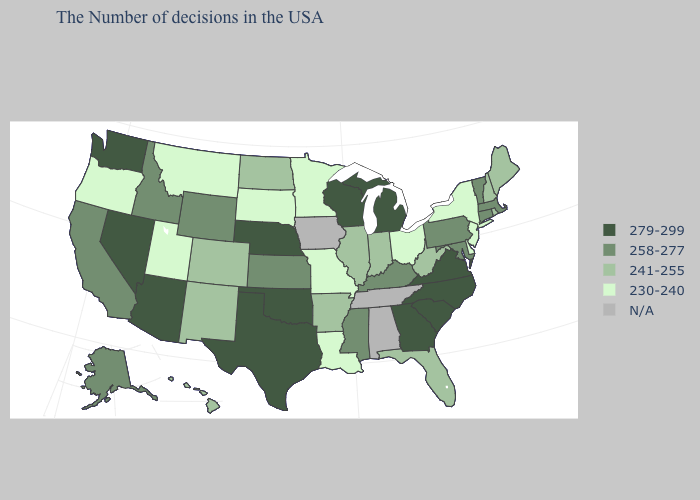Among the states that border Arkansas , which have the lowest value?
Quick response, please. Louisiana, Missouri. Name the states that have a value in the range 241-255?
Quick response, please. Maine, Rhode Island, New Hampshire, West Virginia, Florida, Indiana, Illinois, Arkansas, North Dakota, Colorado, New Mexico, Hawaii. What is the value of Florida?
Quick response, please. 241-255. Does Ohio have the lowest value in the USA?
Quick response, please. Yes. How many symbols are there in the legend?
Write a very short answer. 5. Name the states that have a value in the range 241-255?
Give a very brief answer. Maine, Rhode Island, New Hampshire, West Virginia, Florida, Indiana, Illinois, Arkansas, North Dakota, Colorado, New Mexico, Hawaii. What is the value of Nevada?
Concise answer only. 279-299. Name the states that have a value in the range 241-255?
Be succinct. Maine, Rhode Island, New Hampshire, West Virginia, Florida, Indiana, Illinois, Arkansas, North Dakota, Colorado, New Mexico, Hawaii. What is the lowest value in the Northeast?
Be succinct. 230-240. Does the map have missing data?
Concise answer only. Yes. Does Maine have the highest value in the Northeast?
Quick response, please. No. 